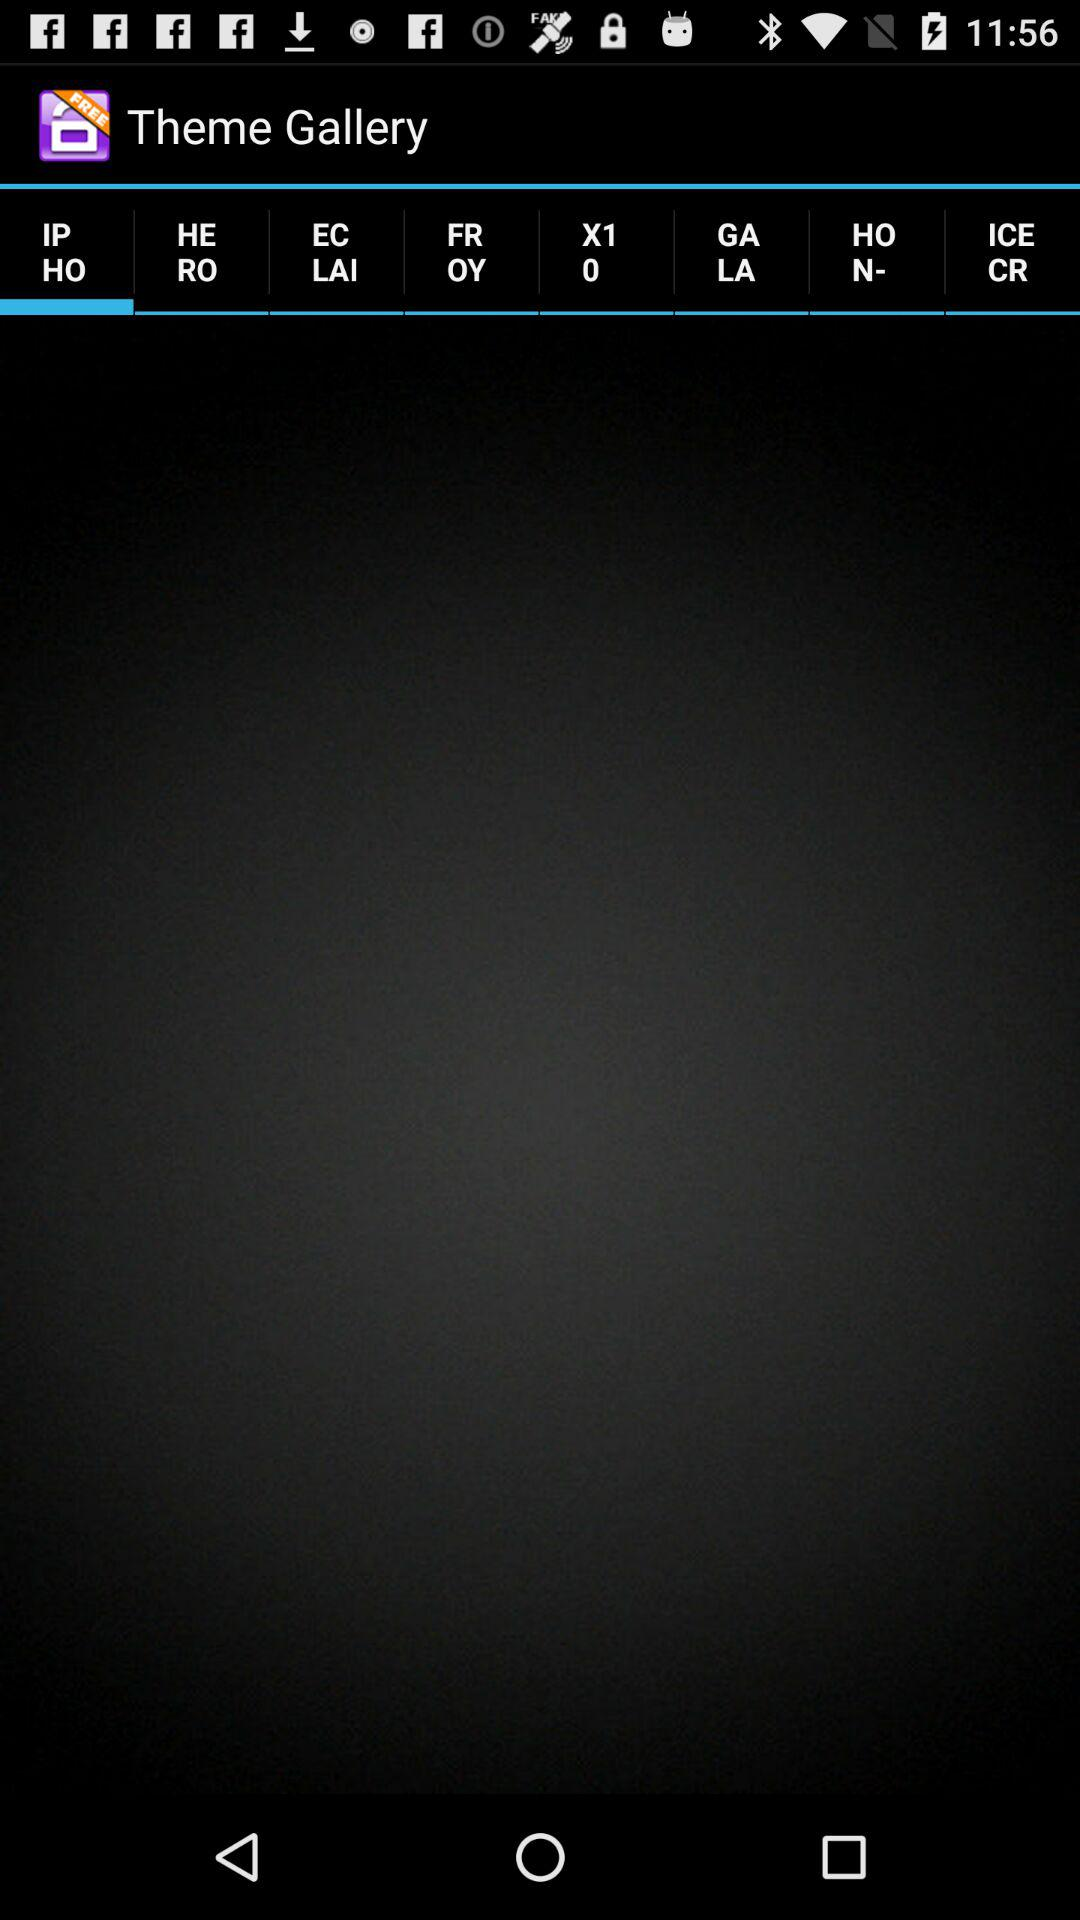Which tab has selected? The selected tab is "IP HO". 